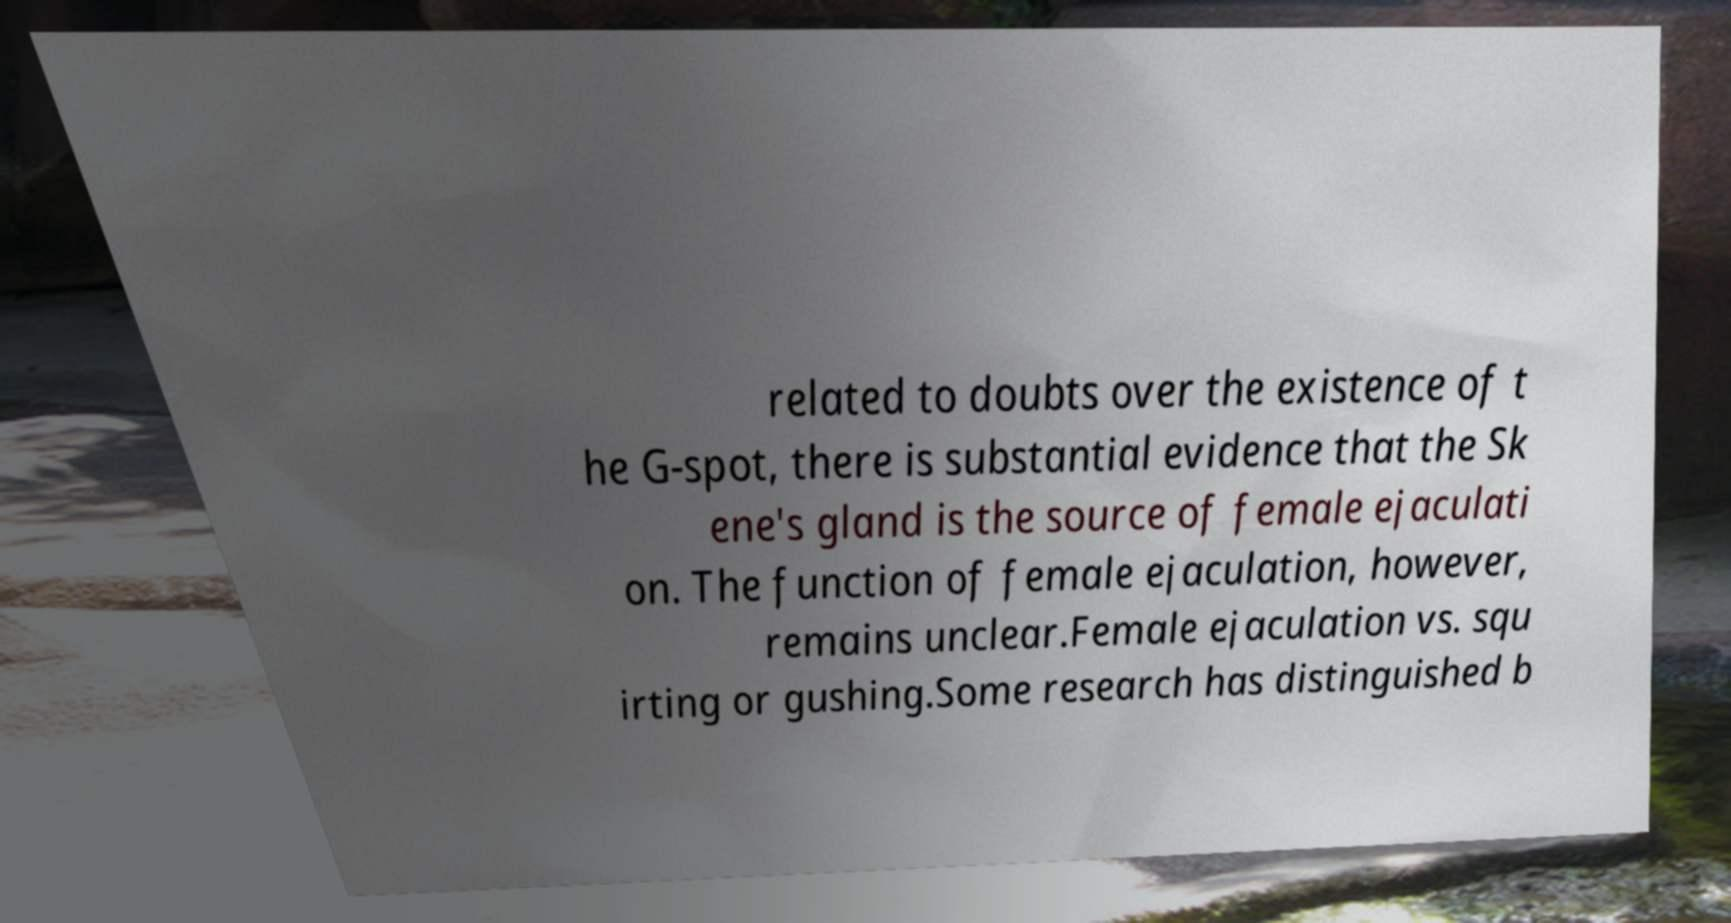For documentation purposes, I need the text within this image transcribed. Could you provide that? related to doubts over the existence of t he G-spot, there is substantial evidence that the Sk ene's gland is the source of female ejaculati on. The function of female ejaculation, however, remains unclear.Female ejaculation vs. squ irting or gushing.Some research has distinguished b 